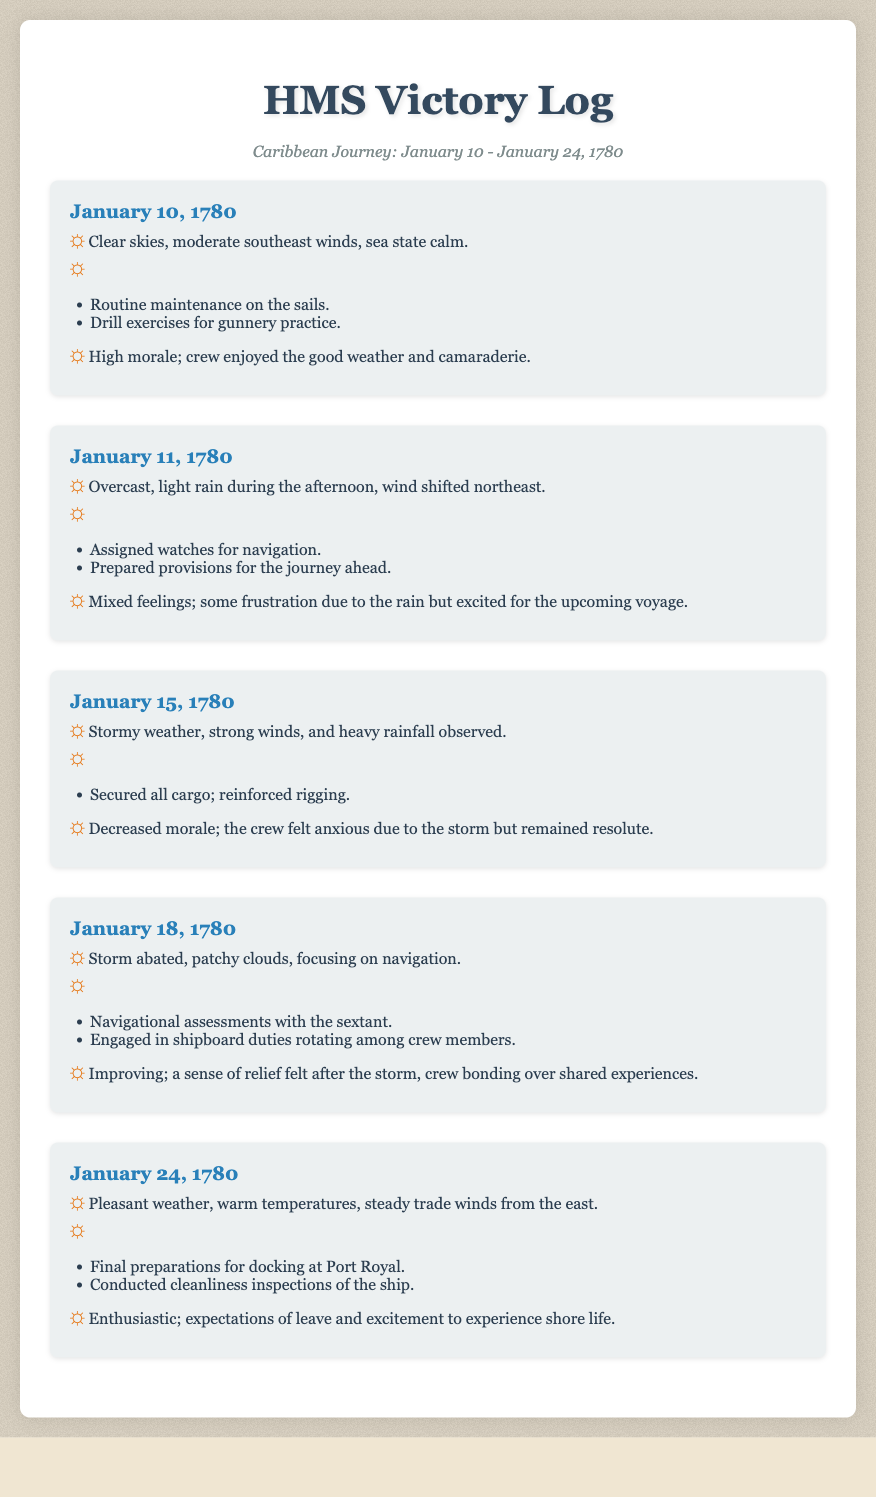what was the weather on January 10, 1780? The weather described for January 10, 1780 is "Clear skies, moderate southeast winds, sea state calm."
Answer: Clear skies what significant event occurred on January 15, 1780? On January 15, 1780, the log notes "Stormy weather, strong winds, and heavy rainfall observed."
Answer: Stormy weather how did the crew feel on January 18, 1780? The morale on January 18, 1780 was noted as "Improving; a sense of relief felt after the storm, crew bonding over shared experiences."
Answer: Improving what duties were performed on January 24, 1780? On January 24, 1780, the duties included "Final preparations for docking at Port Royal" and "Conducted cleanliness inspections of the ship."
Answer: Final preparations how many days did the log cover? The log documented a period from January 10 to January 24, totaling 15 days.
Answer: 15 days what weather condition was noted on January 11, 1780? January 11, 1780 featured "Overcast, light rain during the afternoon, wind shifted northeast."
Answer: Overcast which date had the highest crew morale? The highest morale was noted on January 24, 1780, as "Enthusiastic; expectations of leave and excitement to experience shore life."
Answer: January 24, 1780 what maintenance was done on January 10, 1780? The maintenance performed on January 10, 1780 included "Routine maintenance on the sails."
Answer: Maintenance on the sails how did the crew react to the weather conditions on January 15, 1780? The crew felt "Decreased morale; the crew felt anxious due to the storm but remained resolute."
Answer: Decreased morale 